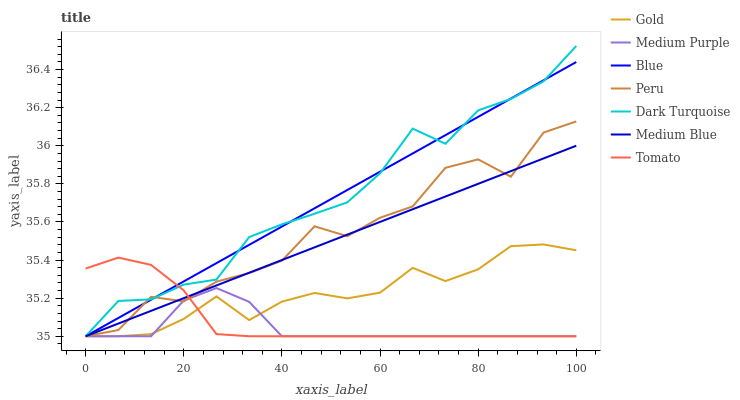Does Medium Purple have the minimum area under the curve?
Answer yes or no. Yes. Does Dark Turquoise have the maximum area under the curve?
Answer yes or no. Yes. Does Tomato have the minimum area under the curve?
Answer yes or no. No. Does Tomato have the maximum area under the curve?
Answer yes or no. No. Is Blue the smoothest?
Answer yes or no. Yes. Is Peru the roughest?
Answer yes or no. Yes. Is Tomato the smoothest?
Answer yes or no. No. Is Tomato the roughest?
Answer yes or no. No. Does Blue have the lowest value?
Answer yes or no. Yes. Does Dark Turquoise have the highest value?
Answer yes or no. Yes. Does Tomato have the highest value?
Answer yes or no. No. Does Medium Blue intersect Dark Turquoise?
Answer yes or no. Yes. Is Medium Blue less than Dark Turquoise?
Answer yes or no. No. Is Medium Blue greater than Dark Turquoise?
Answer yes or no. No. 